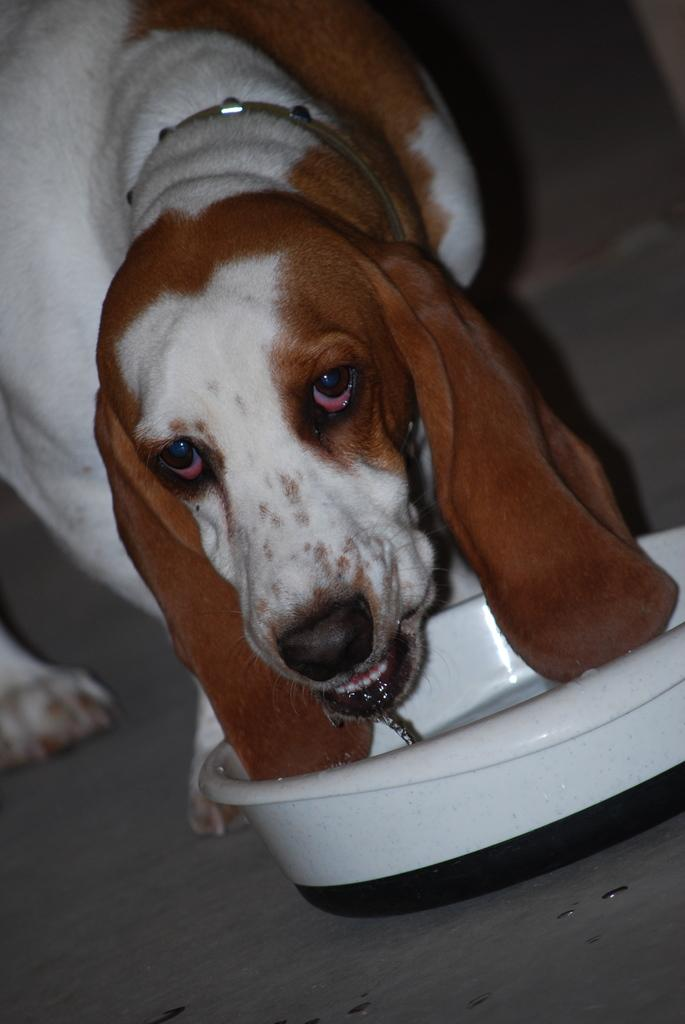What animal is present in the picture? There is a dog in the picture. Can you describe the color of the dog? The dog is brown and white in color. What object is in front of the dog? There is a white color object in front of the dog. What type of peace symbol can be seen on the dog's face? There is no peace symbol or any symbol on the dog's face in the image. 